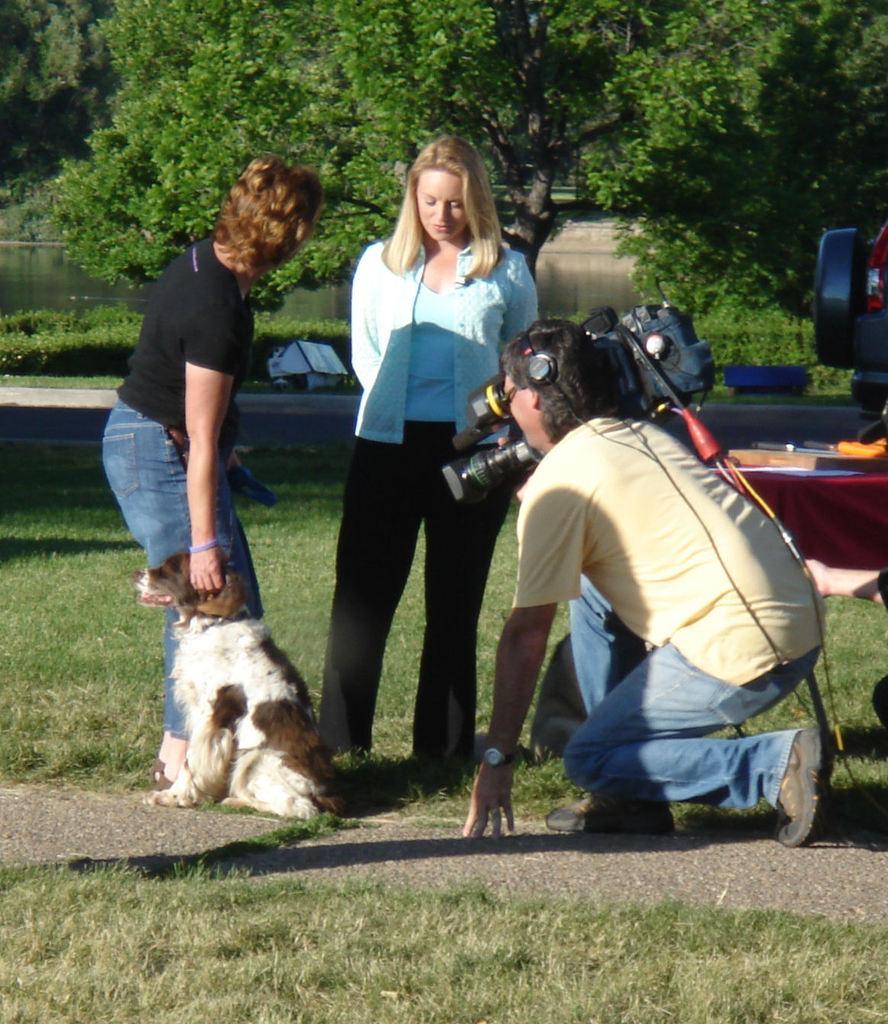In one or two sentences, can you explain what this image depicts? In the middle there are two people standing. Right side of the image a man holding a camera. Bottom of the image there is grass. Bottom left of the image there is a dog. Top left side of the image there is water. At the top of the image there are some trees. 